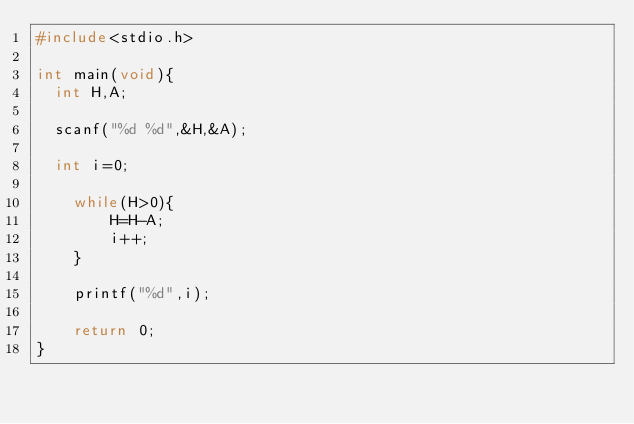Convert code to text. <code><loc_0><loc_0><loc_500><loc_500><_C_>#include<stdio.h>

int main(void){
 	int H,A;

	scanf("%d %d",&H,&A);

 	int i=0;

  	while(H>0){
		    H=H-A;
      	i++;
    }

    printf("%d",i);

  	return 0;
}
</code> 